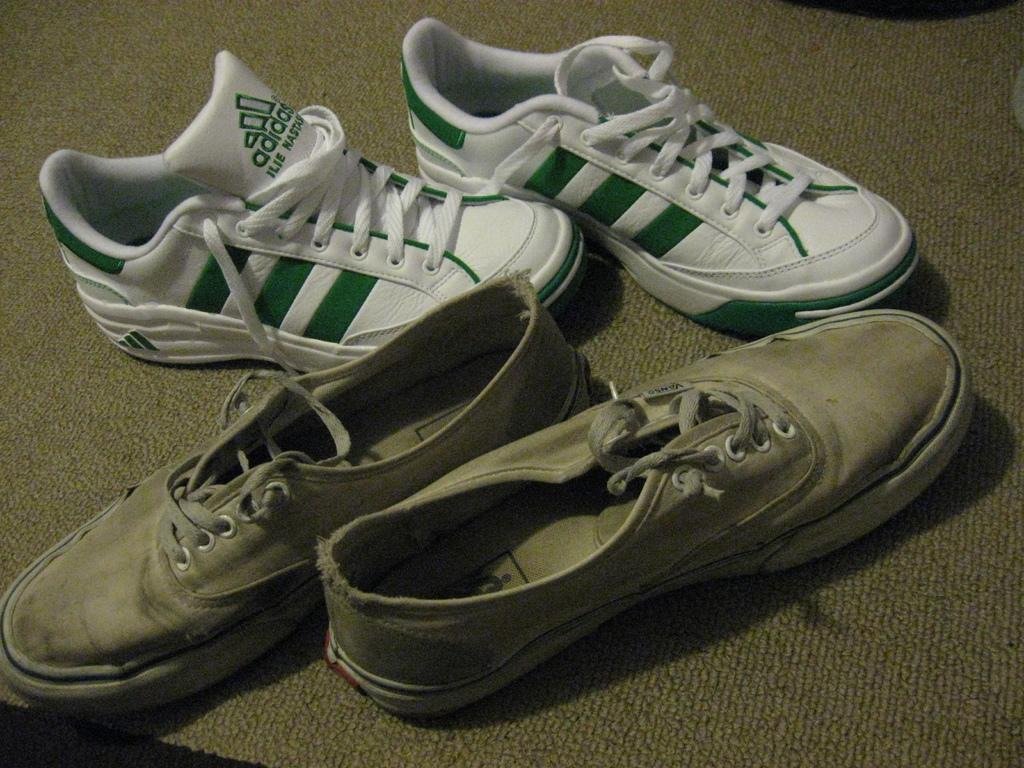How many pairs of shoes are visible in the image? There are two pairs of shoes in the image. Where are the shoes located? The shoes are on a surface. What type of camera is visible in the image? There is no camera present in the image. Is the gate open or closed in the image? There is no gate present in the image. 